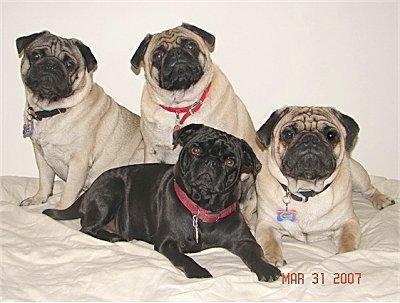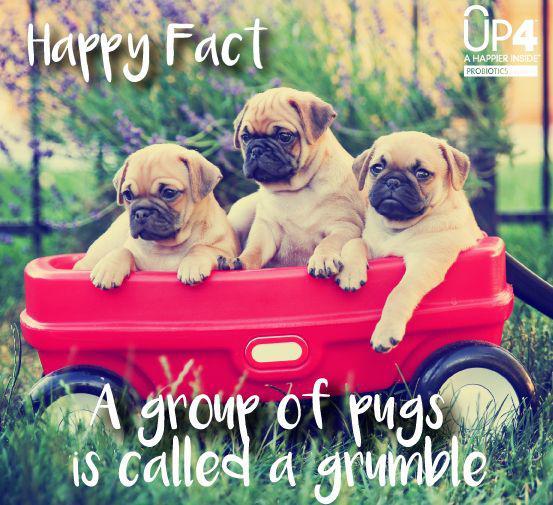The first image is the image on the left, the second image is the image on the right. Examine the images to the left and right. Is the description "One picture has exactly three pugs." accurate? Answer yes or no. Yes. 